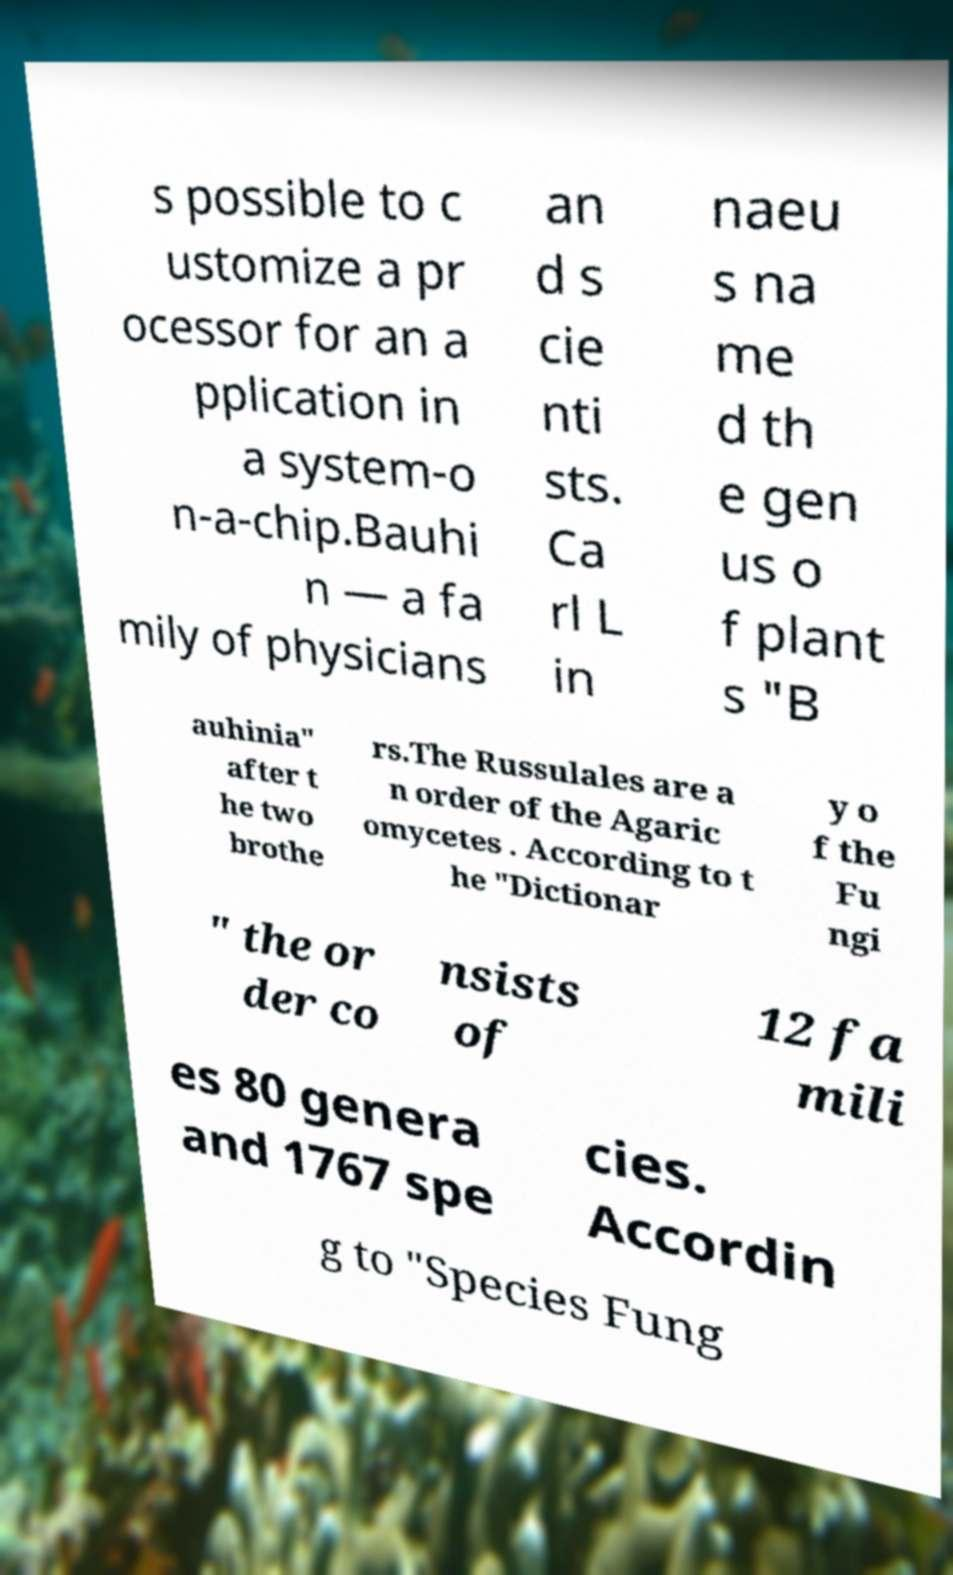There's text embedded in this image that I need extracted. Can you transcribe it verbatim? s possible to c ustomize a pr ocessor for an a pplication in a system-o n-a-chip.Bauhi n — a fa mily of physicians an d s cie nti sts. Ca rl L in naeu s na me d th e gen us o f plant s "B auhinia" after t he two brothe rs.The Russulales are a n order of the Agaric omycetes . According to t he "Dictionar y o f the Fu ngi " the or der co nsists of 12 fa mili es 80 genera and 1767 spe cies. Accordin g to "Species Fung 